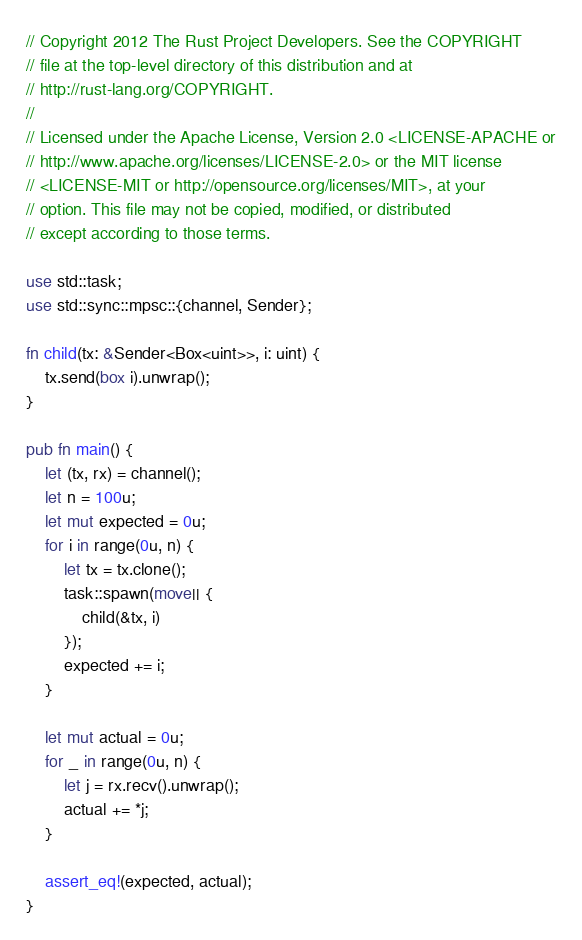<code> <loc_0><loc_0><loc_500><loc_500><_Rust_>// Copyright 2012 The Rust Project Developers. See the COPYRIGHT
// file at the top-level directory of this distribution and at
// http://rust-lang.org/COPYRIGHT.
//
// Licensed under the Apache License, Version 2.0 <LICENSE-APACHE or
// http://www.apache.org/licenses/LICENSE-2.0> or the MIT license
// <LICENSE-MIT or http://opensource.org/licenses/MIT>, at your
// option. This file may not be copied, modified, or distributed
// except according to those terms.

use std::task;
use std::sync::mpsc::{channel, Sender};

fn child(tx: &Sender<Box<uint>>, i: uint) {
    tx.send(box i).unwrap();
}

pub fn main() {
    let (tx, rx) = channel();
    let n = 100u;
    let mut expected = 0u;
    for i in range(0u, n) {
        let tx = tx.clone();
        task::spawn(move|| {
            child(&tx, i)
        });
        expected += i;
    }

    let mut actual = 0u;
    for _ in range(0u, n) {
        let j = rx.recv().unwrap();
        actual += *j;
    }

    assert_eq!(expected, actual);
}
</code> 